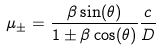Convert formula to latex. <formula><loc_0><loc_0><loc_500><loc_500>\mu _ { \pm } = \frac { \beta \sin ( \theta ) } { 1 \pm \beta \cos ( \theta ) } \frac { c } { D }</formula> 